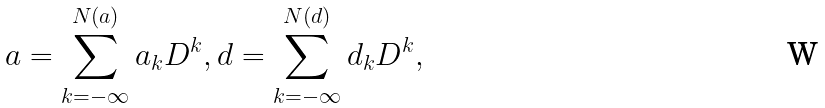<formula> <loc_0><loc_0><loc_500><loc_500>a = \sum _ { k = - \infty } ^ { N ( a ) } a _ { k } D ^ { k } , d = \sum _ { k = - \infty } ^ { N ( d ) } d _ { k } D ^ { k } ,</formula> 